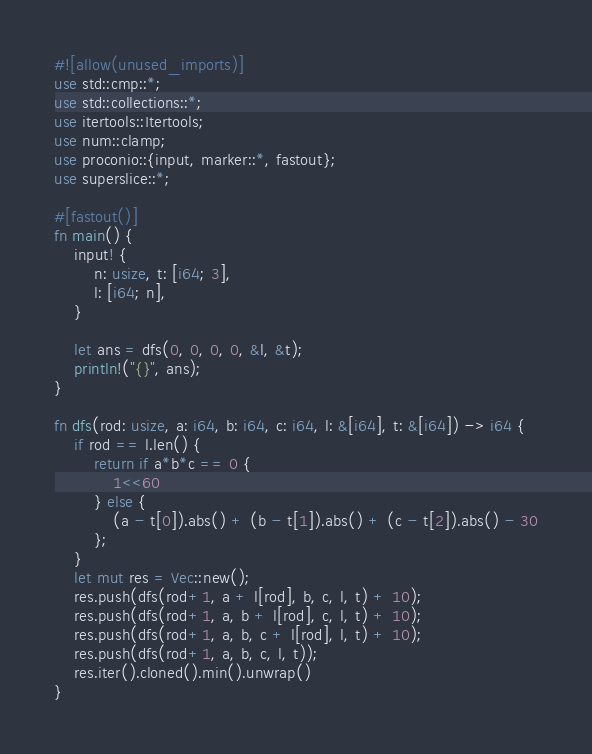Convert code to text. <code><loc_0><loc_0><loc_500><loc_500><_Rust_>#![allow(unused_imports)]
use std::cmp::*;
use std::collections::*;
use itertools::Itertools;
use num::clamp;
use proconio::{input, marker::*, fastout};
use superslice::*;

#[fastout()]
fn main() {
    input! {
        n: usize, t: [i64; 3],
        l: [i64; n],
    }

    let ans = dfs(0, 0, 0, 0, &l, &t);
    println!("{}", ans);
}

fn dfs(rod: usize, a: i64, b: i64, c: i64, l: &[i64], t: &[i64]) -> i64 {
    if rod == l.len() {
        return if a*b*c == 0 {
            1<<60
        } else {
            (a - t[0]).abs() + (b - t[1]).abs() + (c - t[2]).abs() - 30
        };
    }
    let mut res = Vec::new();
    res.push(dfs(rod+1, a + l[rod], b, c, l, t) + 10);
    res.push(dfs(rod+1, a, b + l[rod], c, l, t) + 10);
    res.push(dfs(rod+1, a, b, c + l[rod], l, t) + 10);
    res.push(dfs(rod+1, a, b, c, l, t));
    res.iter().cloned().min().unwrap()    
}</code> 